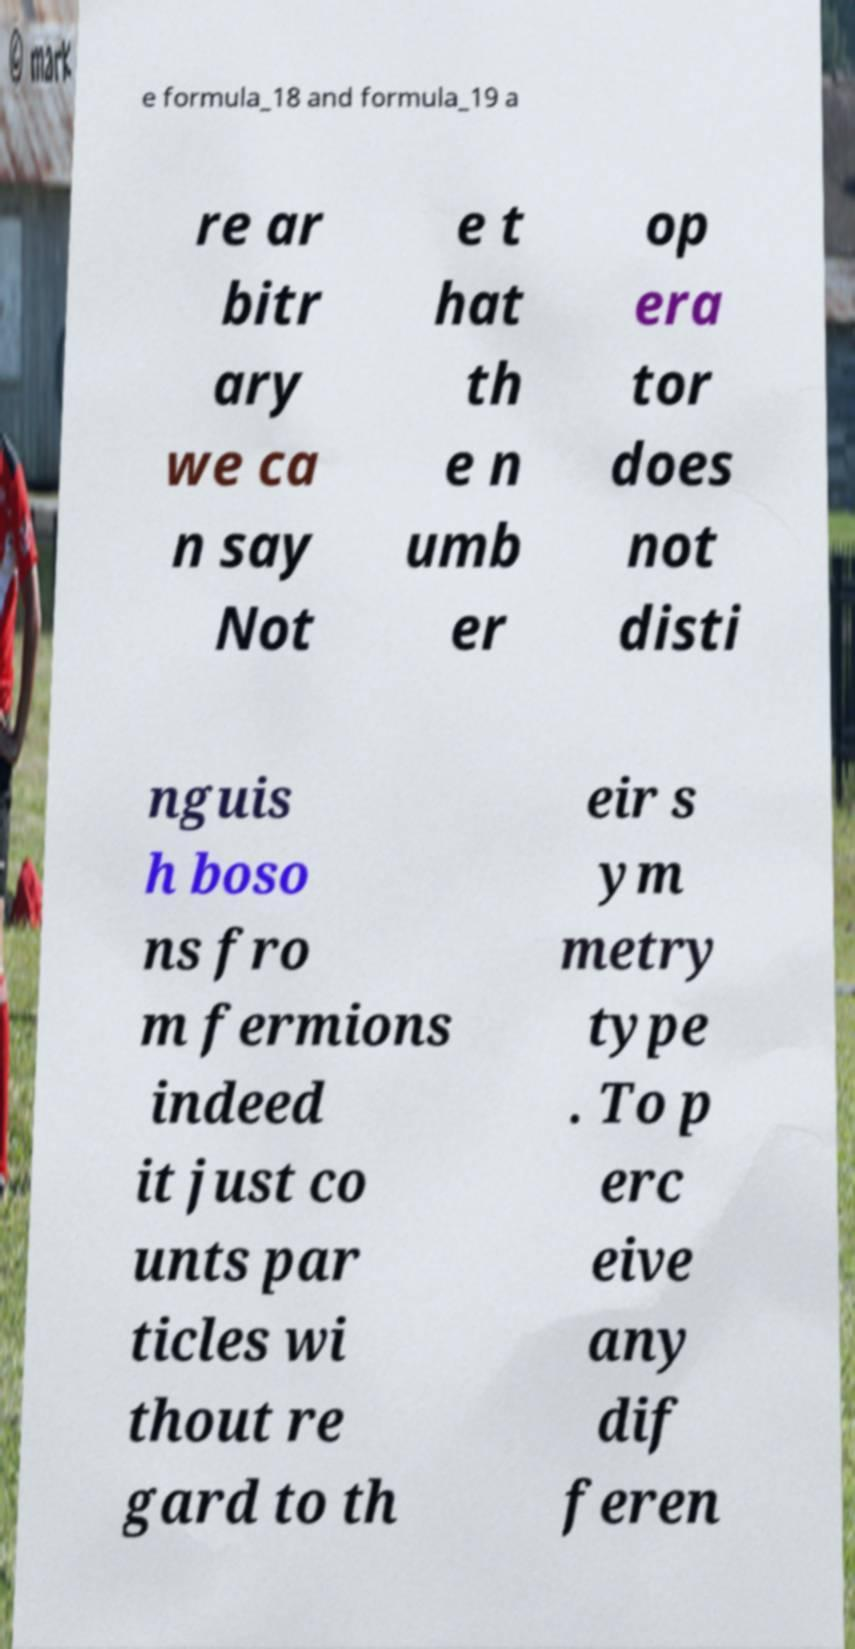Could you assist in decoding the text presented in this image and type it out clearly? e formula_18 and formula_19 a re ar bitr ary we ca n say Not e t hat th e n umb er op era tor does not disti nguis h boso ns fro m fermions indeed it just co unts par ticles wi thout re gard to th eir s ym metry type . To p erc eive any dif feren 